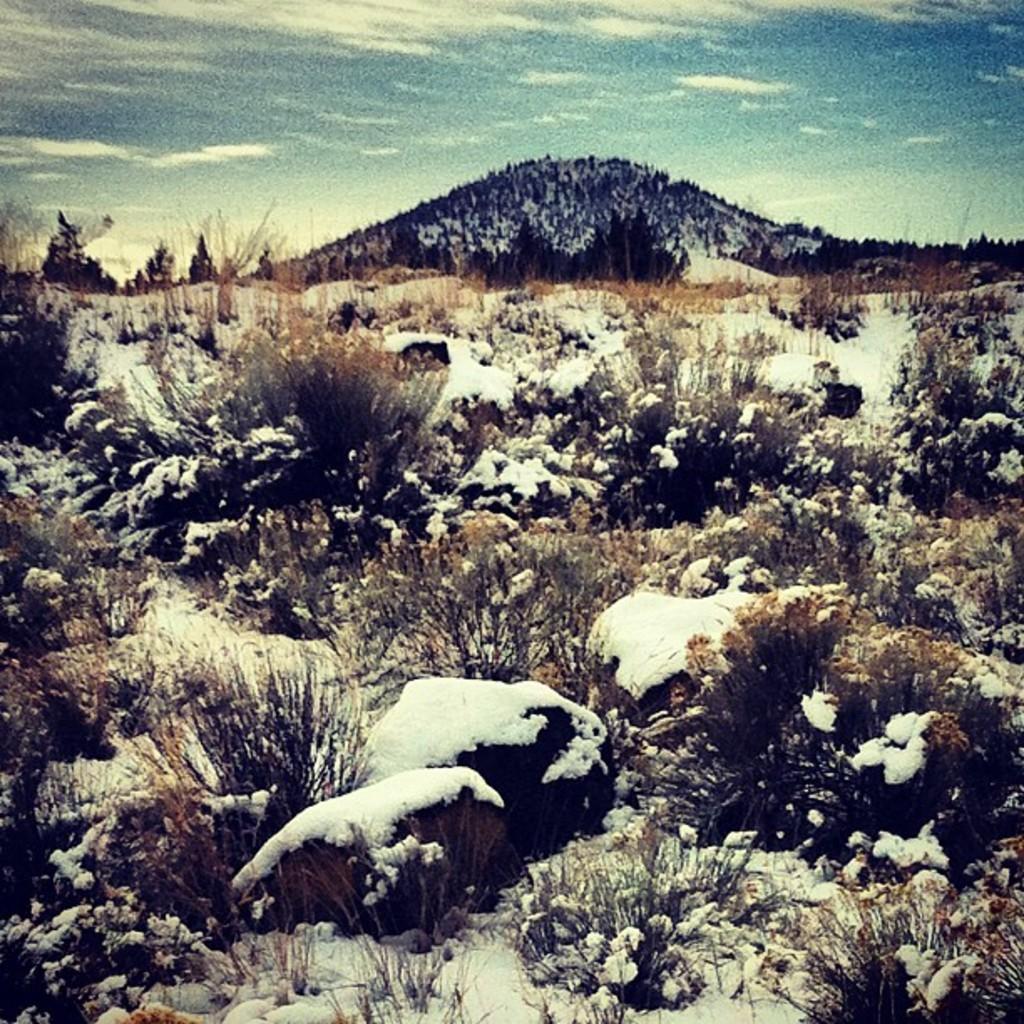In one or two sentences, can you explain what this image depicts? As we can see in the image there are stones, grass, snow, sky and clouds. 